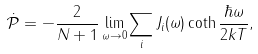<formula> <loc_0><loc_0><loc_500><loc_500>\dot { \mathcal { P } } = - \frac { 2 } { N + 1 } \lim _ { \omega \to 0 } \sum _ { i } J _ { i } ( \omega ) \coth \frac { \hbar { \omega } } { 2 k T } ,</formula> 